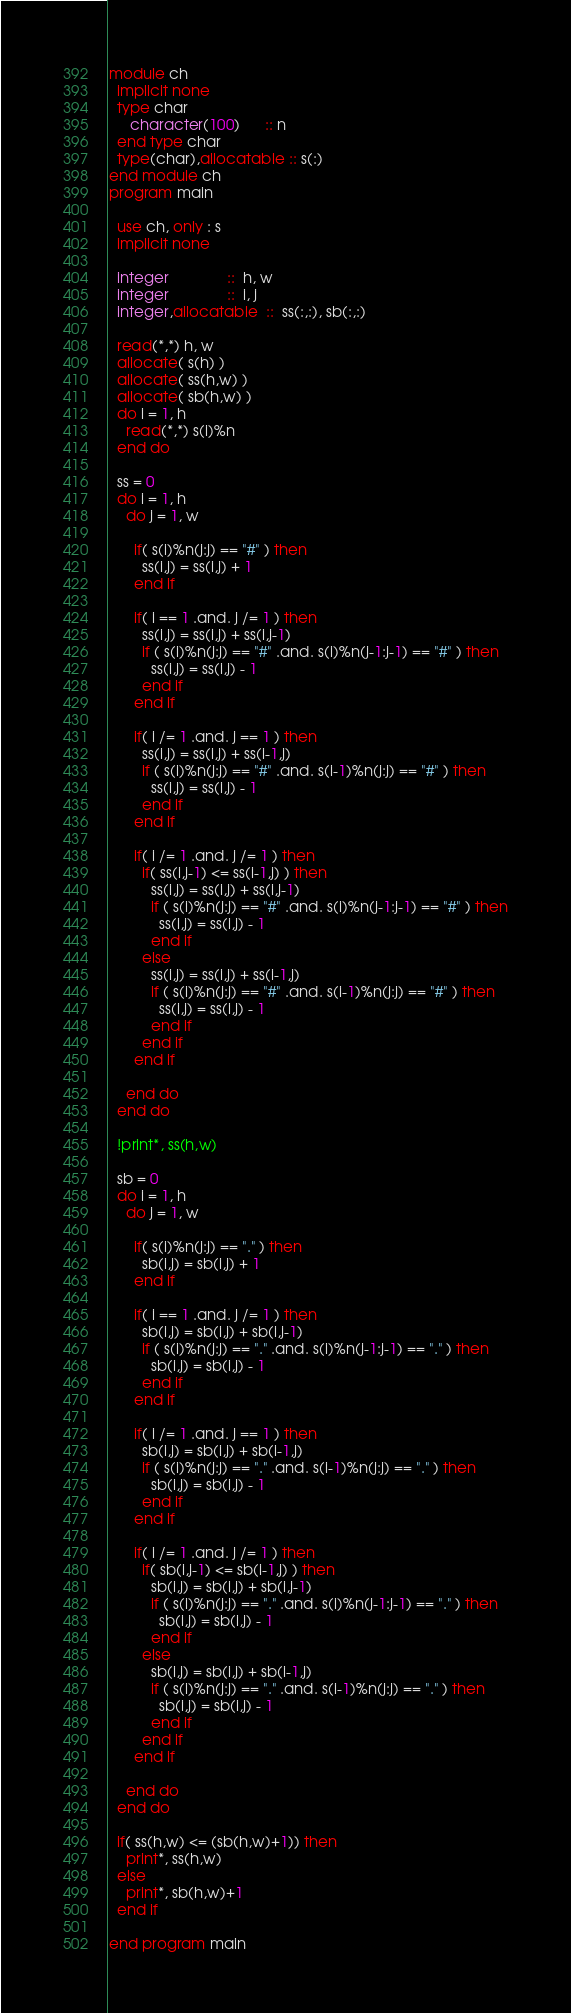<code> <loc_0><loc_0><loc_500><loc_500><_FORTRAN_>module ch
  implicit none
  type char
     character(100)      :: n
  end type char
  type(char),allocatable :: s(:)
end module ch
program main
  
  use ch, only : s
  implicit none
  
  integer              ::  h, w  
  integer              ::  i, j
  integer,allocatable  ::  ss(:,:), sb(:,:)

  read(*,*) h, w
  allocate( s(h) )
  allocate( ss(h,w) )
  allocate( sb(h,w) )
  do i = 1, h
    read(*,*) s(i)%n
  end do
  
  ss = 0
  do i = 1, h
    do j = 1, w
    
      if( s(i)%n(j:j) == "#" ) then
        ss(i,j) = ss(i,j) + 1
      end if
      
      if( i == 1 .and. j /= 1 ) then
        ss(i,j) = ss(i,j) + ss(i,j-1) 
        if ( s(i)%n(j:j) == "#" .and. s(i)%n(j-1:j-1) == "#" ) then
          ss(i,j) = ss(i,j) - 1  
        end if
      end if

      if( i /= 1 .and. j == 1 ) then
        ss(i,j) = ss(i,j) + ss(i-1,j)
        if ( s(i)%n(j:j) == "#" .and. s(i-1)%n(j:j) == "#" ) then
          ss(i,j) = ss(i,j) - 1  
        end if
      end if

      if( i /= 1 .and. j /= 1 ) then
        if( ss(i,j-1) <= ss(i-1,j) ) then   
          ss(i,j) = ss(i,j) + ss(i,j-1) 
          if ( s(i)%n(j:j) == "#" .and. s(i)%n(j-1:j-1) == "#" ) then
            ss(i,j) = ss(i,j) - 1  
          end if
        else
          ss(i,j) = ss(i,j) + ss(i-1,j)
          if ( s(i)%n(j:j) == "#" .and. s(i-1)%n(j:j) == "#" ) then
            ss(i,j) = ss(i,j) - 1  
          end if
        end if
      end if

    end do
  end do
  
  !print*, ss(h,w)

  sb = 0
  do i = 1, h
    do j = 1, w
    
      if( s(i)%n(j:j) == "." ) then
        sb(i,j) = sb(i,j) + 1
      end if
      
      if( i == 1 .and. j /= 1 ) then
        sb(i,j) = sb(i,j) + sb(i,j-1) 
        if ( s(i)%n(j:j) == "." .and. s(i)%n(j-1:j-1) == "." ) then
          sb(i,j) = sb(i,j) - 1  
        end if
      end if

      if( i /= 1 .and. j == 1 ) then
        sb(i,j) = sb(i,j) + sb(i-1,j)
        if ( s(i)%n(j:j) == "." .and. s(i-1)%n(j:j) == "." ) then
          sb(i,j) = sb(i,j) - 1  
        end if
      end if

      if( i /= 1 .and. j /= 1 ) then
        if( sb(i,j-1) <= sb(i-1,j) ) then   
          sb(i,j) = sb(i,j) + sb(i,j-1) 
          if ( s(i)%n(j:j) == "." .and. s(i)%n(j-1:j-1) == "." ) then
            sb(i,j) = sb(i,j) - 1  
          end if
        else
          sb(i,j) = sb(i,j) + sb(i-1,j)
          if ( s(i)%n(j:j) == "." .and. s(i-1)%n(j:j) == "." ) then
            sb(i,j) = sb(i,j) - 1  
          end if
        end if
      end if

    end do
  end do
    
  if( ss(h,w) <= (sb(h,w)+1)) then
    print*, ss(h,w)
  else
    print*, sb(h,w)+1
  end if

end program main
</code> 